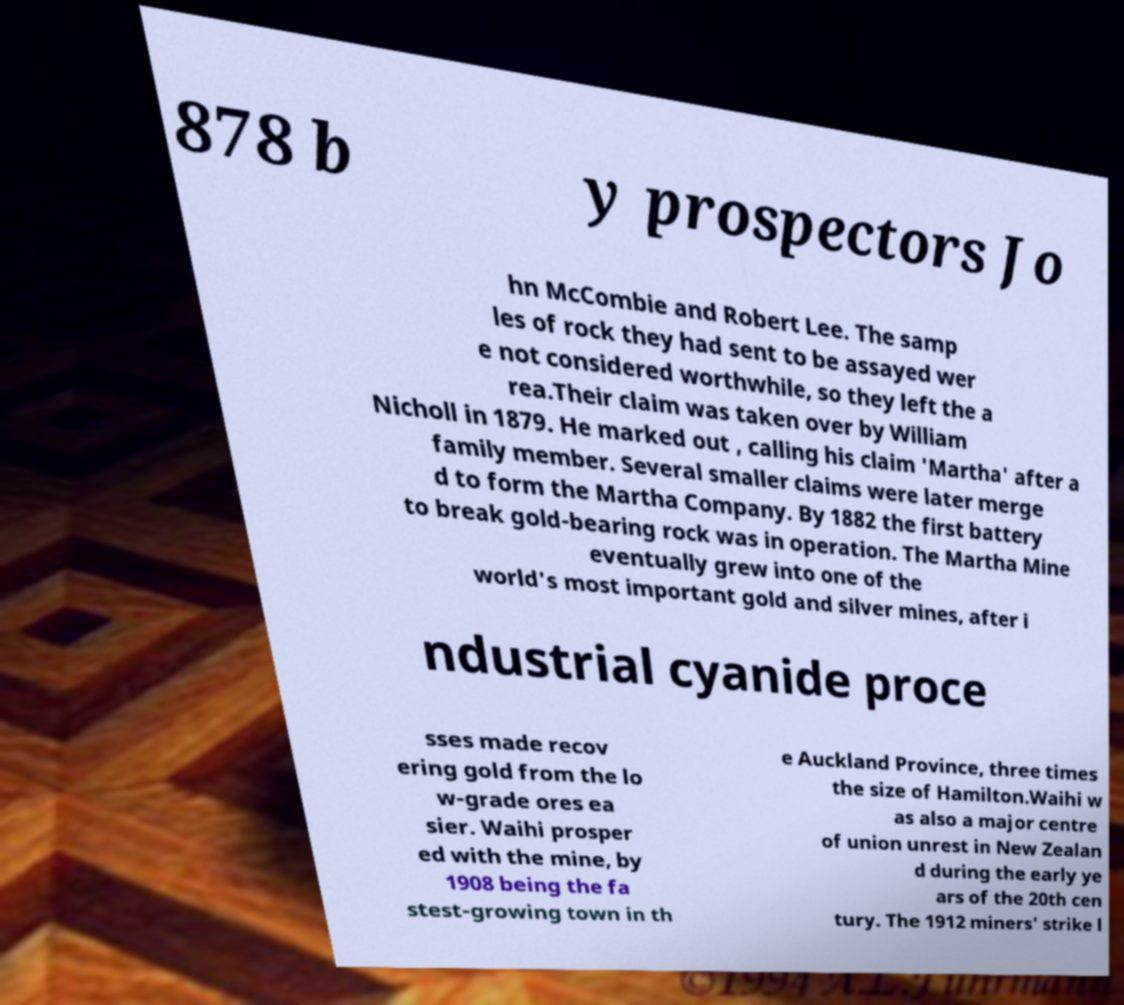Can you read and provide the text displayed in the image?This photo seems to have some interesting text. Can you extract and type it out for me? 878 b y prospectors Jo hn McCombie and Robert Lee. The samp les of rock they had sent to be assayed wer e not considered worthwhile, so they left the a rea.Their claim was taken over by William Nicholl in 1879. He marked out , calling his claim 'Martha' after a family member. Several smaller claims were later merge d to form the Martha Company. By 1882 the first battery to break gold-bearing rock was in operation. The Martha Mine eventually grew into one of the world's most important gold and silver mines, after i ndustrial cyanide proce sses made recov ering gold from the lo w-grade ores ea sier. Waihi prosper ed with the mine, by 1908 being the fa stest-growing town in th e Auckland Province, three times the size of Hamilton.Waihi w as also a major centre of union unrest in New Zealan d during the early ye ars of the 20th cen tury. The 1912 miners' strike l 